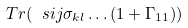Convert formula to latex. <formula><loc_0><loc_0><loc_500><loc_500>T r ( \ s i j \sigma _ { k l } \dots ( 1 + \Gamma _ { 1 1 } ) )</formula> 